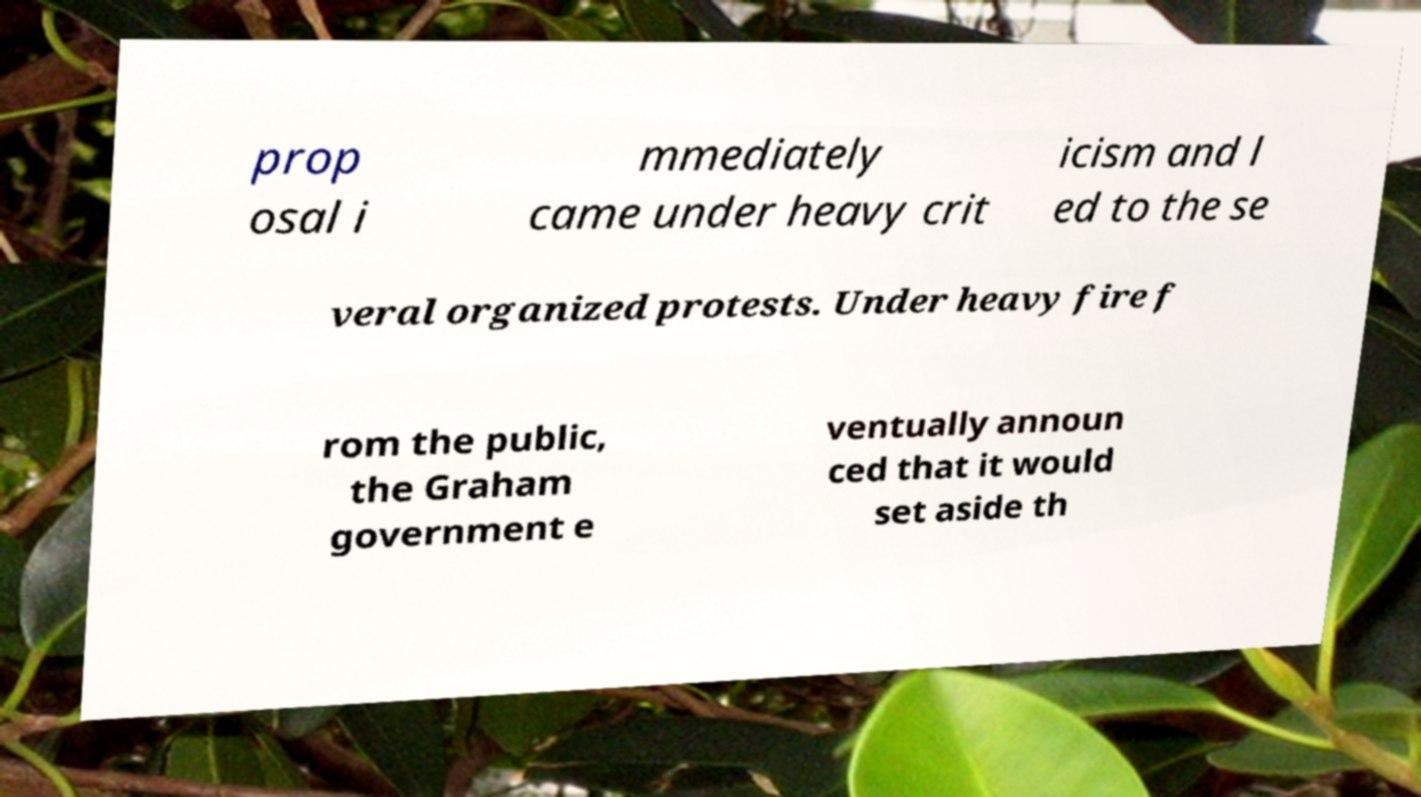Can you accurately transcribe the text from the provided image for me? prop osal i mmediately came under heavy crit icism and l ed to the se veral organized protests. Under heavy fire f rom the public, the Graham government e ventually announ ced that it would set aside th 